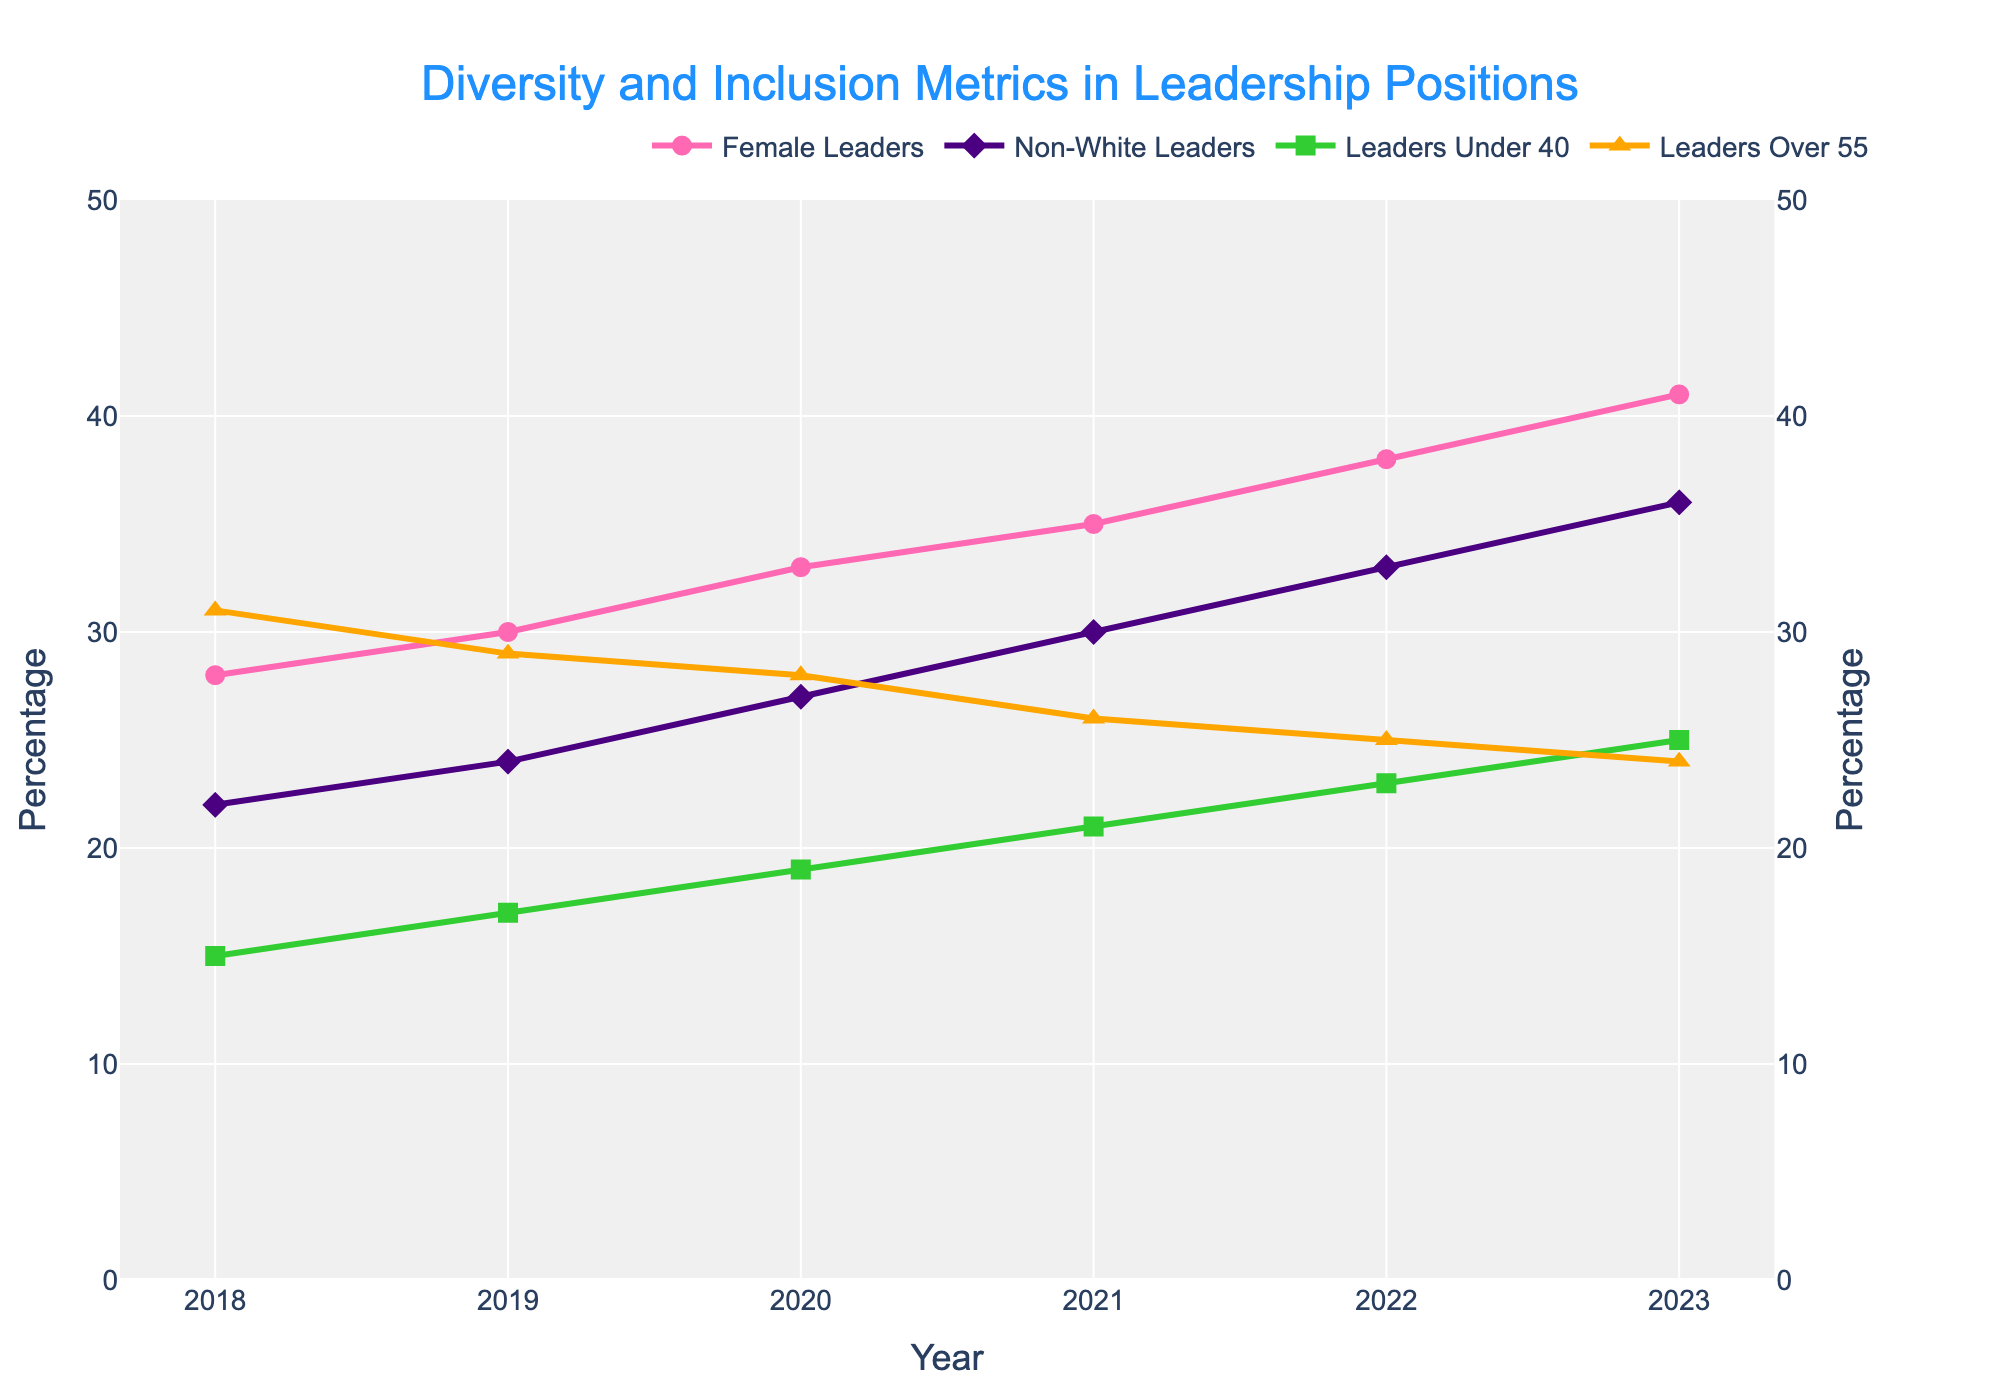what is the percentage increase in female leaders from 2018 to 2023? In 2018, the percentage of female leaders is 28%, and in 2023, it is 41%. The increase is \(41 - 28 = 13\) percentage points.
Answer: 13 Which group experienced the highest percentage increase from 2018 to 2023? Calculate the percentage increase for each group from 2018 to 2023: Female Leaders: \(41 - 28 = 13\); Non-White Leaders: \(36 - 22 = 14\); Leaders Under 40: \(25 - 15 = 10\); Leaders Over 55: \(24 - 31 = -7\). Non-White Leaders experienced the highest increase.
Answer: Non-White Leaders How did the percentage of Leaders Over 55 change from 2018 to 2023? In 2018, the percentage of Leaders Over 55 is 31%, and in 2023, it is 24%. The change is \(24 - 31 = -7\), which is a decrease.
Answer: Decreased by 7 Are the percentages of Non-White Leaders and Leaders Under 40 higher or lower in 2023 compared to 2020? In 2020, the percentage of Non-White Leaders is 27% and Leaders Under 40 is 19%. In 2023, Non-White Leaders is 36% and Leaders Under 40 is 25%. Both are higher in 2023.
Answer: Higher By how much did the percentage of Leaders Under 40 increase on average each year from 2018 to 2023? The initial value in 2018 is 15%, and the final value in 2023 is 25%. Over 5 years, the increase is \(25 - 15 = 10\) percentage points. The average annual increase is \(10 / 5 = 2\) percentage points per year.
Answer: 2 Which group showed continuous growth without any decline over the years? Checking each year’s values for all groups: Female Leaders grew from 28% to 41%, Non-White Leaders increased from 22% to 36%, and Leaders Under 40 increased from 15% to 25%. None of these groups experienced a decline. Leaders Over 55 decreased from 31% to 24%. All except Leaders Over 55 showed continuous growth.
Answer: Female Leaders, Non-White Leaders, Leaders Under 40 What was the largest year-on-year increase observed across any category? Calculate the year-on-year increases for each category: Female Leaders (2, 3, 2, 3, 3), Non-White Leaders (2, 3, 3, 3, 3), Leaders Under 40 (2, 2, 2, 2, 2), Leaders Over 55 (-2, -1, -2, -1, -1). The largest increase observed is 3%.
Answer: 3 Which category had the smallest change in percentage from 2018 to 2023? Calculate the changes: Female Leaders (13), Non-White Leaders (14), Leaders Under 40 (10), Leaders Over 55 (-7). Leaders Over 55 had the smallest change, though it's a negative change.
Answer: Leaders Over 55 How does the percentage of Leaders Under 40 compare to Leaders Over 55 in 2023? In 2023, Leaders Under 40 is 25%, and Leaders Over 55 is 24%. Leaders Under 40 has a higher percentage by \(25 - 24 = 1\) percentage point.
Answer: Leaders Under 40 is higher Which category increased every single year? Female Leaders, Non-White Leaders, and Leaders Under 40 each increased every year without any decrease. Verify by observing the trend lines.
Answer: Female Leaders, Non-White Leaders, Leaders Under 40 